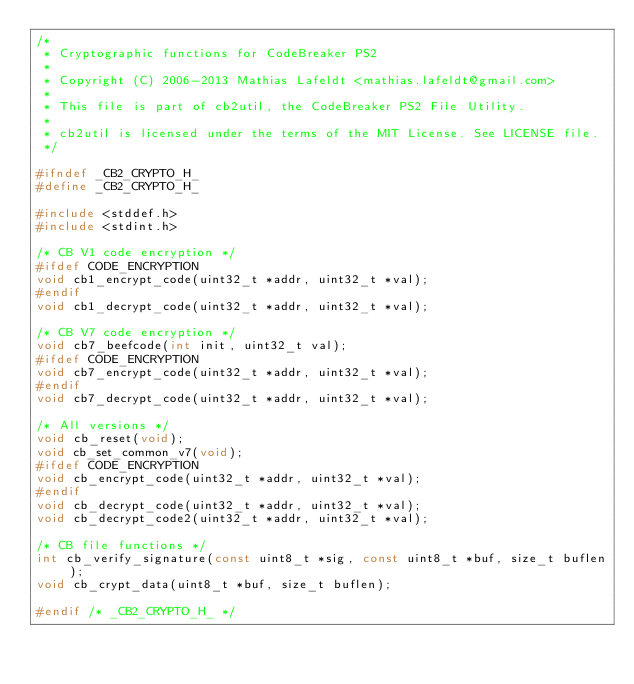<code> <loc_0><loc_0><loc_500><loc_500><_C_>/*
 * Cryptographic functions for CodeBreaker PS2
 *
 * Copyright (C) 2006-2013 Mathias Lafeldt <mathias.lafeldt@gmail.com>
 *
 * This file is part of cb2util, the CodeBreaker PS2 File Utility.
 *
 * cb2util is licensed under the terms of the MIT License. See LICENSE file.
 */

#ifndef _CB2_CRYPTO_H_
#define _CB2_CRYPTO_H_

#include <stddef.h>
#include <stdint.h>

/* CB V1 code encryption */
#ifdef CODE_ENCRYPTION
void cb1_encrypt_code(uint32_t *addr, uint32_t *val);
#endif
void cb1_decrypt_code(uint32_t *addr, uint32_t *val);

/* CB V7 code encryption */
void cb7_beefcode(int init, uint32_t val);
#ifdef CODE_ENCRYPTION
void cb7_encrypt_code(uint32_t *addr, uint32_t *val);
#endif
void cb7_decrypt_code(uint32_t *addr, uint32_t *val);

/* All versions */
void cb_reset(void);
void cb_set_common_v7(void);
#ifdef CODE_ENCRYPTION
void cb_encrypt_code(uint32_t *addr, uint32_t *val);
#endif
void cb_decrypt_code(uint32_t *addr, uint32_t *val);
void cb_decrypt_code2(uint32_t *addr, uint32_t *val);

/* CB file functions */
int cb_verify_signature(const uint8_t *sig, const uint8_t *buf, size_t buflen);
void cb_crypt_data(uint8_t *buf, size_t buflen);

#endif /* _CB2_CRYPTO_H_ */
</code> 